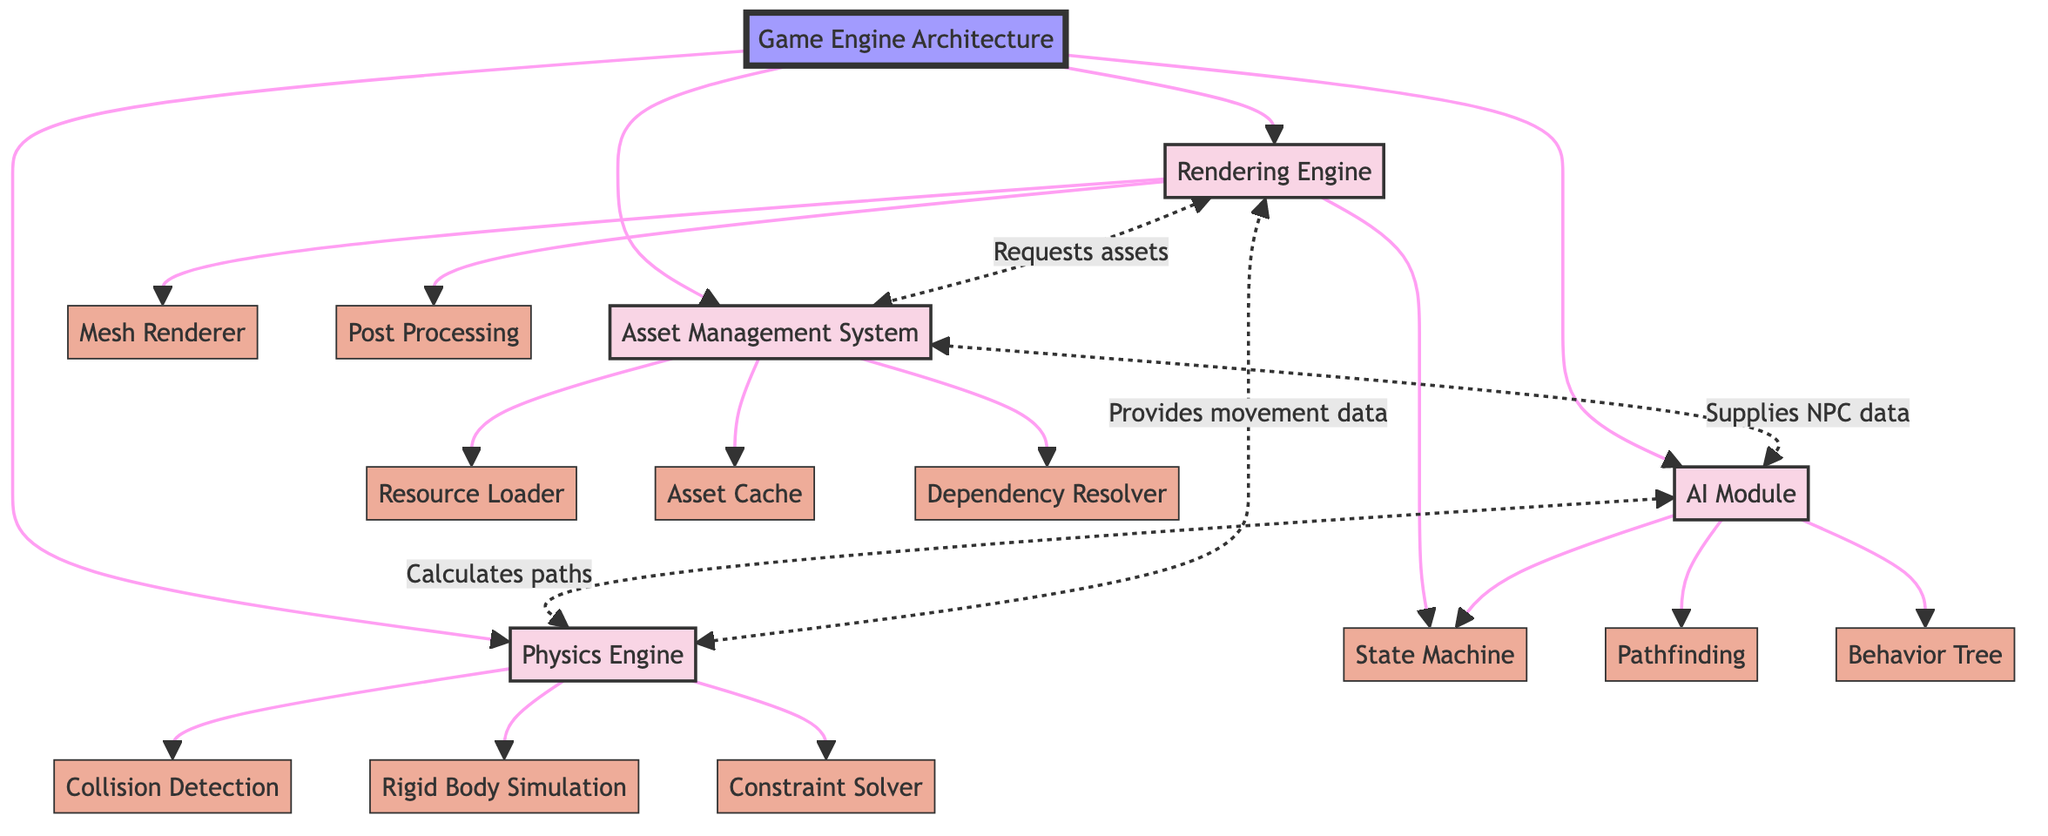What is the main purpose of the Rendering Engine? The Rendering Engine handles all graphics rendering tasks, converting scene data into pixels on the screen. This purpose is explicitly stated in the component's description in the diagram.
Answer: Handles all graphics rendering tasks, converting scene data into pixels on the screen How many subcomponents does the Physics Engine have? The Physics Engine has three subcomponents listed in the diagram: Collision Detection, Rigid Body Simulation, and Constraint Solver. Counting these gives the total of three.
Answer: 3 What does the AI Module receive from the Asset Management System? The Asset Management System supplies the AI Module data such as NPC textures and animations, as specified in the interaction line that connects these two components.
Answer: NPC textures and animations Which component requests shaders from the Asset Management System? The Rendering Engine requests shaders, textures, and models from the Asset Management System, as noted in the diagram's interaction arrows.
Answer: Rendering Engine What is the relationship between the AI Module and the Physics Engine? The AI Module calculates movement paths that require collision detection and physical constraints from the Physics Engine, indicating a directional interaction between these components.
Answer: Calculates movement paths What does the Rendering Engine provide to the Physics Engine? The Physics Engine receives positional and movement data from the Rendering Engine, which is detailed in the interaction line between these two components.
Answer: Positional and movement data How does the Physics Engine interact with the Rendering Engine? The Physics Engine provides the Rendering Engine with positional and movement data, which is essential for rendering frames correctly. This is reflected in the diagram's interaction description.
Answer: Provides movement data Name a subcomponent of the Asset Management System. The Asset Management System comprises three subcomponents listed in the diagram: Resource Loader, Asset Cache, and Dependency Resolver. Any of these can be an answer.
Answer: Resource Loader (or Asset Cache, or Dependency Resolver) 